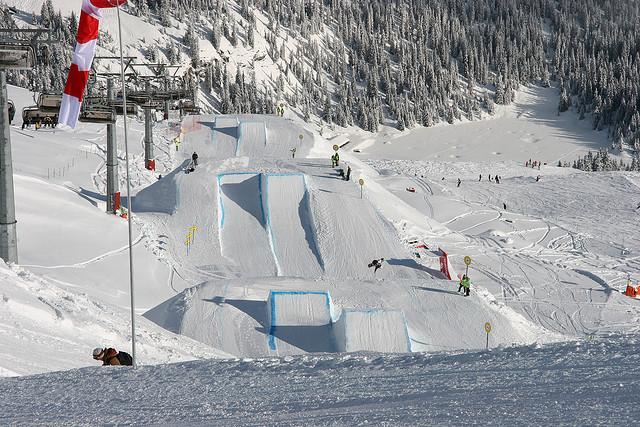Where was the photo taken?
Be succinct. Mountain. Are there lots of people on the snow covered hillside?
Quick response, please. Yes. What is red and white striped?
Concise answer only. Flag. 